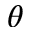<formula> <loc_0><loc_0><loc_500><loc_500>\theta</formula> 